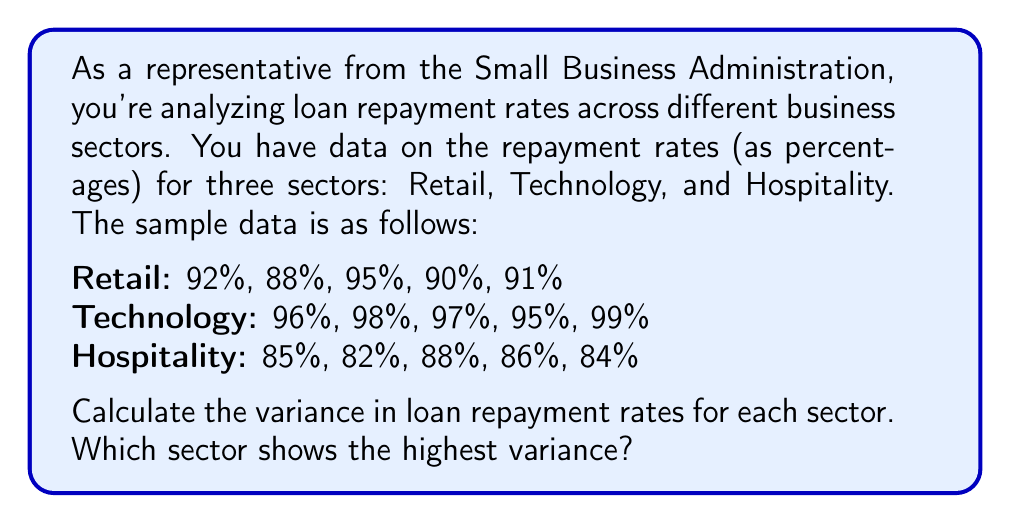Help me with this question. To calculate the variance for each sector, we'll follow these steps:

1. Calculate the mean (average) repayment rate for each sector.
2. Calculate the squared differences from the mean for each data point.
3. Find the average of these squared differences (the variance).

Let's do this for each sector:

1. Retail Sector:

Mean: $\mu_R = \frac{92 + 88 + 95 + 90 + 91}{5} = 91.2\%$

Squared differences: 
$(92-91.2)^2 = 0.64$
$(88-91.2)^2 = 10.24$
$(95-91.2)^2 = 14.44$
$(90-91.2)^2 = 1.44$
$(91-91.2)^2 = 0.04$

Variance: $\sigma_R^2 = \frac{0.64 + 10.24 + 14.44 + 1.44 + 0.04}{5} = 5.36$

2. Technology Sector:

Mean: $\mu_T = \frac{96 + 98 + 97 + 95 + 99}{5} = 97\%$

Squared differences:
$(96-97)^2 = 1$
$(98-97)^2 = 1$
$(97-97)^2 = 0$
$(95-97)^2 = 4$
$(99-97)^2 = 4$

Variance: $\sigma_T^2 = \frac{1 + 1 + 0 + 4 + 4}{5} = 2$

3. Hospitality Sector:

Mean: $\mu_H = \frac{85 + 82 + 88 + 86 + 84}{5} = 85\%$

Squared differences:
$(85-85)^2 = 0$
$(82-85)^2 = 9$
$(88-85)^2 = 9$
$(86-85)^2 = 1$
$(84-85)^2 = 1$

Variance: $\sigma_H^2 = \frac{0 + 9 + 9 + 1 + 1}{5} = 4$

Comparing the variances:
Retail: 5.36
Technology: 2
Hospitality: 4

The Retail sector has the highest variance.
Answer: Retail sector, with a variance of 5.36 